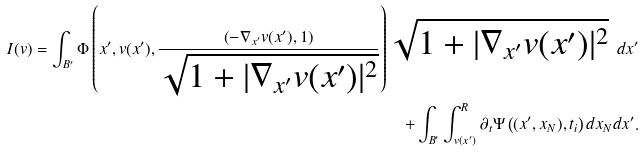Convert formula to latex. <formula><loc_0><loc_0><loc_500><loc_500>I ( v ) = \int _ { B ^ { \prime } } \Phi \left ( x ^ { \prime } , v ( x ^ { \prime } ) , \frac { \left ( - \nabla _ { x ^ { \prime } } v ( x ^ { \prime } ) , 1 \right ) } { \sqrt { 1 + | \nabla _ { x ^ { \prime } } v ( x ^ { \prime } ) | ^ { 2 } } } \right ) \sqrt { 1 + | \nabla _ { x ^ { \prime } } v ( x ^ { \prime } ) | ^ { 2 } } \ d x ^ { \prime } \\ + \int _ { B ^ { \prime } } \int ^ { R } _ { v ( x ^ { \prime } ) } \partial _ { t } \Psi \left ( ( x ^ { \prime } , x _ { N } ) , t _ { i } \right ) d x _ { N } d x ^ { \prime } .</formula> 